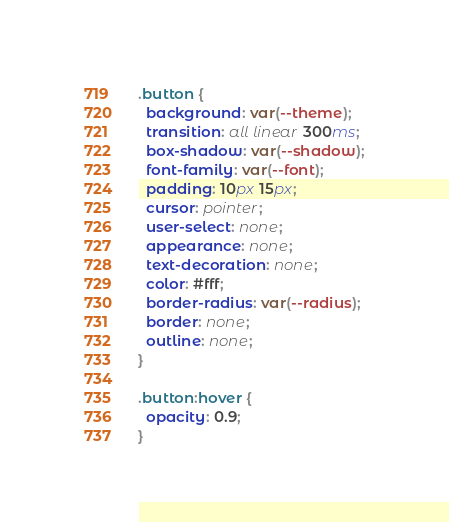<code> <loc_0><loc_0><loc_500><loc_500><_CSS_>.button {
  background: var(--theme);
  transition: all linear 300ms;
  box-shadow: var(--shadow);
  font-family: var(--font);
  padding: 10px 15px;
  cursor: pointer;
  user-select: none;
  appearance: none;
  text-decoration: none;
  color: #fff;
  border-radius: var(--radius);
  border: none;
  outline: none;
}

.button:hover {
  opacity: 0.9;
}</code> 